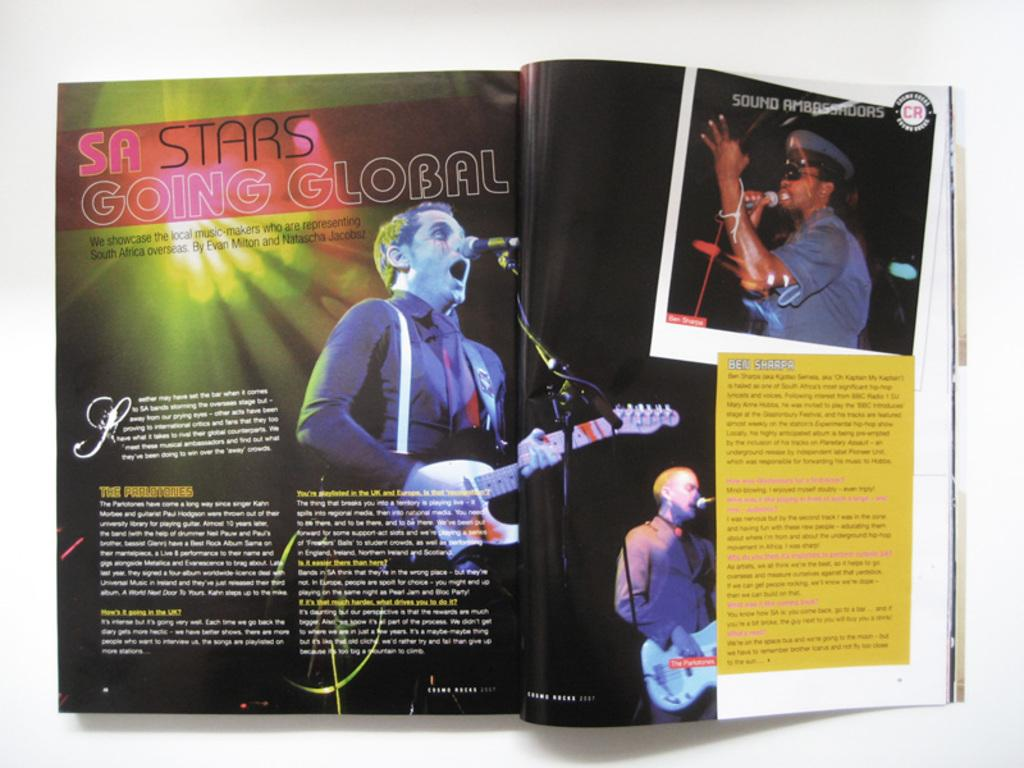What is placed on the white surface in the image? There is a book on a white surface. What can be found inside the book? The book contains an image of three people. What objects are included in the image within the book? The image in the book includes microphones (mics) and guitars. Is there any text present in the image within the book? Yes, the image in the book contains some text. What type of soup is being served to the flock of birds in the image? There is no soup or birds present in the image; it features a book with an image of three people and objects. 